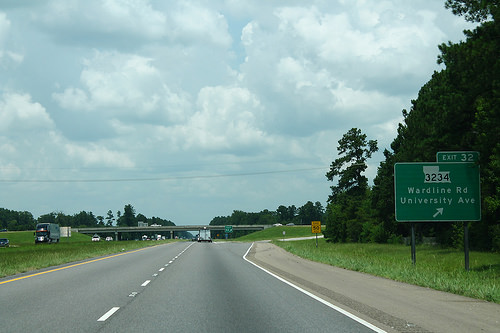<image>
Is the semi above the car? No. The semi is not positioned above the car. The vertical arrangement shows a different relationship. 